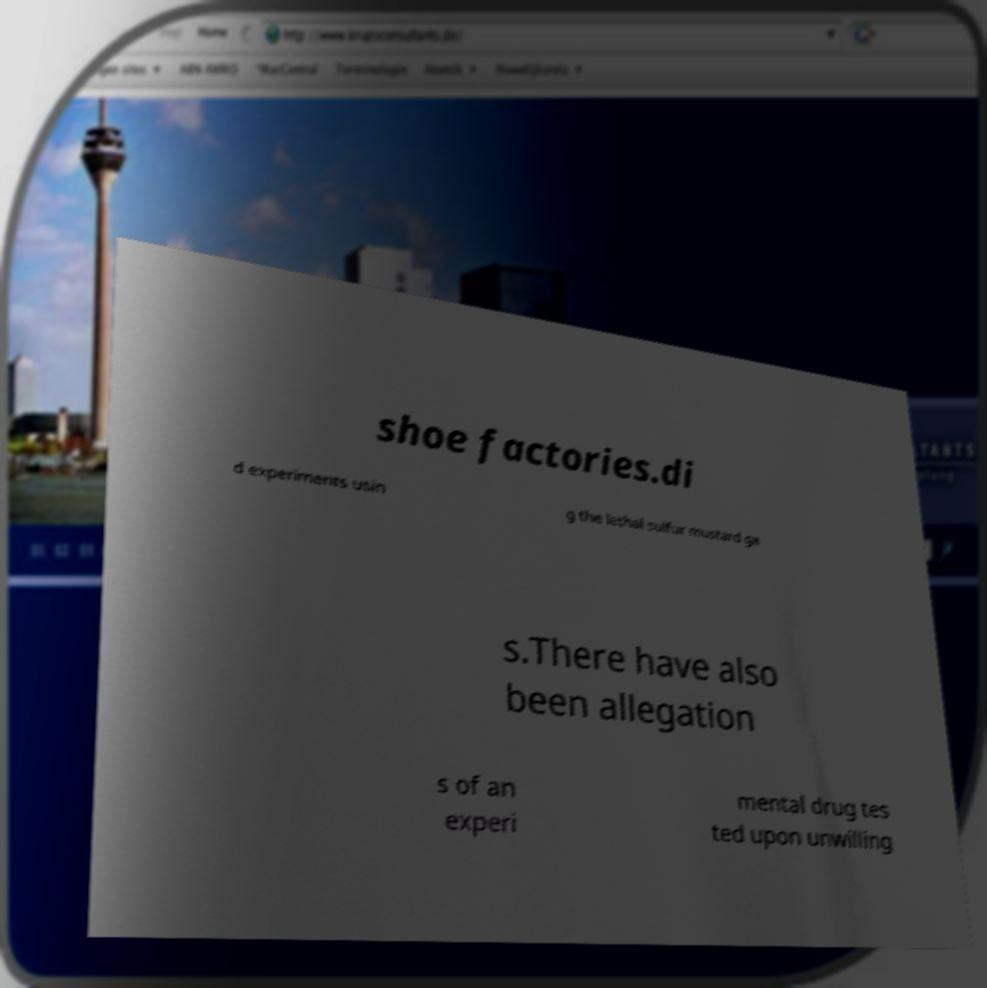Please read and relay the text visible in this image. What does it say? shoe factories.di d experiments usin g the lethal sulfur mustard ga s.There have also been allegation s of an experi mental drug tes ted upon unwilling 